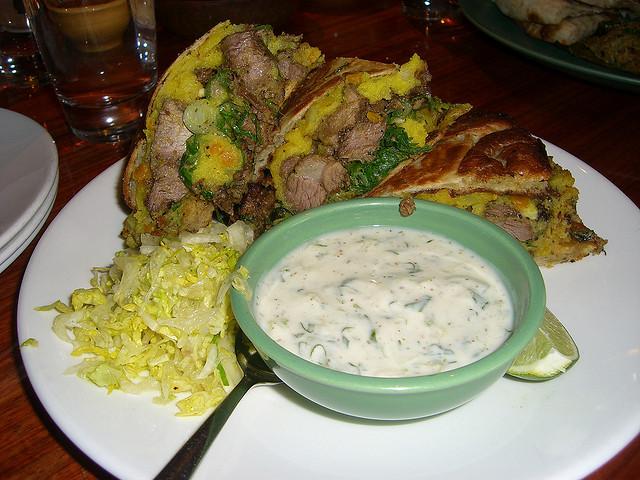What color is the plate?
Quick response, please. White. What is on the plate?
Answer briefly. Food. Is there a spoon on the plate?
Quick response, please. Yes. Has the meal begun?
Answer briefly. No. 